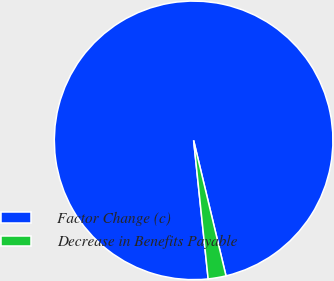<chart> <loc_0><loc_0><loc_500><loc_500><pie_chart><fcel>Factor Change (c)<fcel>Decrease in Benefits Payable<nl><fcel>97.93%<fcel>2.07%<nl></chart> 